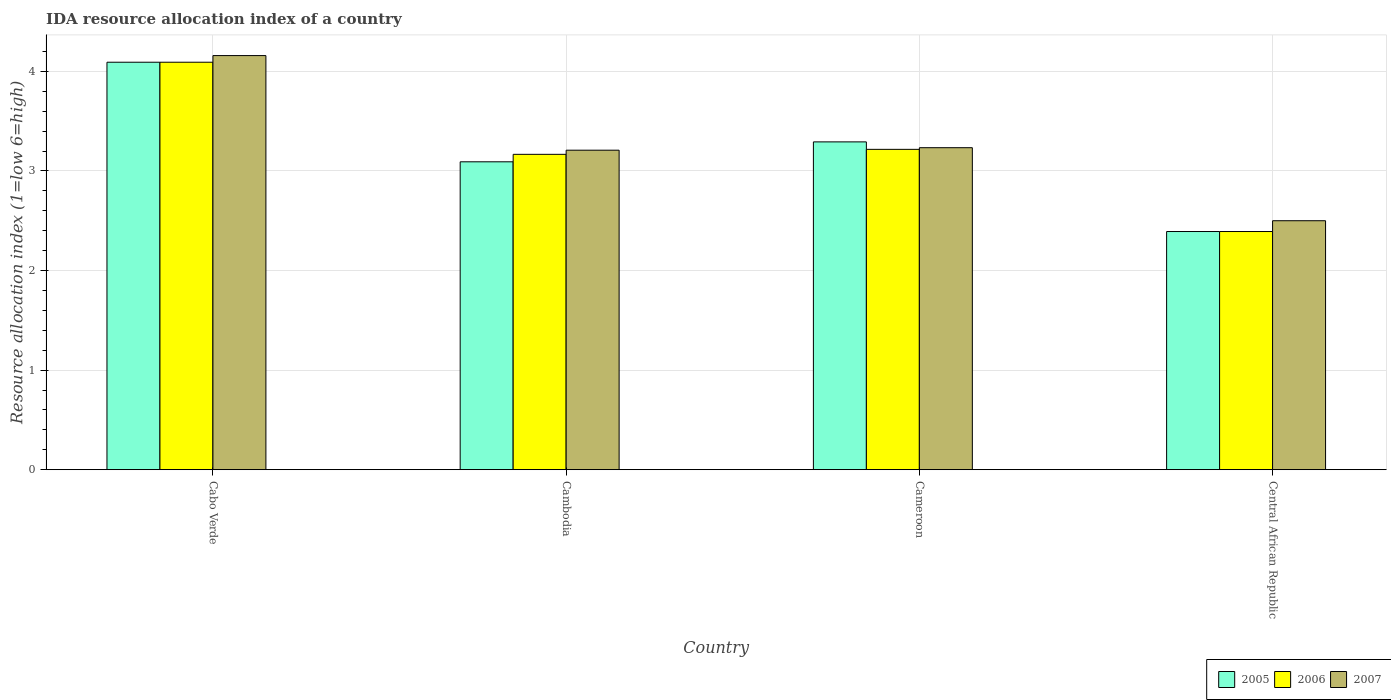How many different coloured bars are there?
Provide a short and direct response. 3. How many groups of bars are there?
Offer a very short reply. 4. How many bars are there on the 2nd tick from the right?
Offer a very short reply. 3. What is the label of the 4th group of bars from the left?
Give a very brief answer. Central African Republic. In how many cases, is the number of bars for a given country not equal to the number of legend labels?
Your answer should be compact. 0. What is the IDA resource allocation index in 2007 in Cameroon?
Keep it short and to the point. 3.23. Across all countries, what is the maximum IDA resource allocation index in 2005?
Offer a very short reply. 4.09. Across all countries, what is the minimum IDA resource allocation index in 2007?
Your response must be concise. 2.5. In which country was the IDA resource allocation index in 2006 maximum?
Your response must be concise. Cabo Verde. In which country was the IDA resource allocation index in 2007 minimum?
Ensure brevity in your answer.  Central African Republic. What is the total IDA resource allocation index in 2006 in the graph?
Your answer should be compact. 12.87. What is the difference between the IDA resource allocation index in 2006 in Cabo Verde and that in Cambodia?
Offer a very short reply. 0.92. What is the difference between the IDA resource allocation index in 2005 in Cambodia and the IDA resource allocation index in 2006 in Cameroon?
Your response must be concise. -0.12. What is the average IDA resource allocation index in 2006 per country?
Make the answer very short. 3.22. What is the difference between the IDA resource allocation index of/in 2005 and IDA resource allocation index of/in 2006 in Cameroon?
Ensure brevity in your answer.  0.08. In how many countries, is the IDA resource allocation index in 2005 greater than 2.2?
Keep it short and to the point. 4. What is the ratio of the IDA resource allocation index in 2007 in Cabo Verde to that in Central African Republic?
Ensure brevity in your answer.  1.66. Is the IDA resource allocation index in 2005 in Cambodia less than that in Central African Republic?
Offer a very short reply. No. Is the difference between the IDA resource allocation index in 2005 in Cambodia and Cameroon greater than the difference between the IDA resource allocation index in 2006 in Cambodia and Cameroon?
Your response must be concise. No. What is the difference between the highest and the second highest IDA resource allocation index in 2006?
Keep it short and to the point. -0.05. What is the difference between the highest and the lowest IDA resource allocation index in 2005?
Give a very brief answer. 1.7. In how many countries, is the IDA resource allocation index in 2006 greater than the average IDA resource allocation index in 2006 taken over all countries?
Ensure brevity in your answer.  2. What does the 3rd bar from the right in Cameroon represents?
Provide a short and direct response. 2005. Are the values on the major ticks of Y-axis written in scientific E-notation?
Ensure brevity in your answer.  No. Does the graph contain any zero values?
Ensure brevity in your answer.  No. Where does the legend appear in the graph?
Make the answer very short. Bottom right. How many legend labels are there?
Ensure brevity in your answer.  3. What is the title of the graph?
Make the answer very short. IDA resource allocation index of a country. Does "1987" appear as one of the legend labels in the graph?
Provide a short and direct response. No. What is the label or title of the X-axis?
Ensure brevity in your answer.  Country. What is the label or title of the Y-axis?
Offer a very short reply. Resource allocation index (1=low 6=high). What is the Resource allocation index (1=low 6=high) of 2005 in Cabo Verde?
Provide a succinct answer. 4.09. What is the Resource allocation index (1=low 6=high) in 2006 in Cabo Verde?
Your answer should be compact. 4.09. What is the Resource allocation index (1=low 6=high) in 2007 in Cabo Verde?
Ensure brevity in your answer.  4.16. What is the Resource allocation index (1=low 6=high) in 2005 in Cambodia?
Your answer should be very brief. 3.09. What is the Resource allocation index (1=low 6=high) in 2006 in Cambodia?
Offer a very short reply. 3.17. What is the Resource allocation index (1=low 6=high) in 2007 in Cambodia?
Make the answer very short. 3.21. What is the Resource allocation index (1=low 6=high) of 2005 in Cameroon?
Provide a short and direct response. 3.29. What is the Resource allocation index (1=low 6=high) in 2006 in Cameroon?
Your response must be concise. 3.22. What is the Resource allocation index (1=low 6=high) of 2007 in Cameroon?
Your response must be concise. 3.23. What is the Resource allocation index (1=low 6=high) of 2005 in Central African Republic?
Offer a very short reply. 2.39. What is the Resource allocation index (1=low 6=high) of 2006 in Central African Republic?
Offer a terse response. 2.39. What is the Resource allocation index (1=low 6=high) of 2007 in Central African Republic?
Your response must be concise. 2.5. Across all countries, what is the maximum Resource allocation index (1=low 6=high) in 2005?
Offer a very short reply. 4.09. Across all countries, what is the maximum Resource allocation index (1=low 6=high) in 2006?
Keep it short and to the point. 4.09. Across all countries, what is the maximum Resource allocation index (1=low 6=high) in 2007?
Offer a very short reply. 4.16. Across all countries, what is the minimum Resource allocation index (1=low 6=high) of 2005?
Keep it short and to the point. 2.39. Across all countries, what is the minimum Resource allocation index (1=low 6=high) of 2006?
Keep it short and to the point. 2.39. What is the total Resource allocation index (1=low 6=high) of 2005 in the graph?
Give a very brief answer. 12.87. What is the total Resource allocation index (1=low 6=high) in 2006 in the graph?
Your response must be concise. 12.87. What is the difference between the Resource allocation index (1=low 6=high) in 2006 in Cabo Verde and that in Cambodia?
Ensure brevity in your answer.  0.93. What is the difference between the Resource allocation index (1=low 6=high) of 2007 in Cabo Verde and that in Cambodia?
Offer a terse response. 0.95. What is the difference between the Resource allocation index (1=low 6=high) in 2005 in Cabo Verde and that in Cameroon?
Make the answer very short. 0.8. What is the difference between the Resource allocation index (1=low 6=high) in 2007 in Cabo Verde and that in Cameroon?
Offer a very short reply. 0.93. What is the difference between the Resource allocation index (1=low 6=high) in 2005 in Cabo Verde and that in Central African Republic?
Give a very brief answer. 1.7. What is the difference between the Resource allocation index (1=low 6=high) in 2006 in Cabo Verde and that in Central African Republic?
Your answer should be very brief. 1.7. What is the difference between the Resource allocation index (1=low 6=high) in 2007 in Cabo Verde and that in Central African Republic?
Offer a terse response. 1.66. What is the difference between the Resource allocation index (1=low 6=high) of 2005 in Cambodia and that in Cameroon?
Ensure brevity in your answer.  -0.2. What is the difference between the Resource allocation index (1=low 6=high) in 2007 in Cambodia and that in Cameroon?
Offer a terse response. -0.03. What is the difference between the Resource allocation index (1=low 6=high) in 2006 in Cambodia and that in Central African Republic?
Ensure brevity in your answer.  0.78. What is the difference between the Resource allocation index (1=low 6=high) of 2007 in Cambodia and that in Central African Republic?
Provide a succinct answer. 0.71. What is the difference between the Resource allocation index (1=low 6=high) of 2006 in Cameroon and that in Central African Republic?
Keep it short and to the point. 0.82. What is the difference between the Resource allocation index (1=low 6=high) of 2007 in Cameroon and that in Central African Republic?
Make the answer very short. 0.73. What is the difference between the Resource allocation index (1=low 6=high) in 2005 in Cabo Verde and the Resource allocation index (1=low 6=high) in 2006 in Cambodia?
Make the answer very short. 0.93. What is the difference between the Resource allocation index (1=low 6=high) of 2005 in Cabo Verde and the Resource allocation index (1=low 6=high) of 2007 in Cambodia?
Your answer should be very brief. 0.88. What is the difference between the Resource allocation index (1=low 6=high) in 2006 in Cabo Verde and the Resource allocation index (1=low 6=high) in 2007 in Cambodia?
Ensure brevity in your answer.  0.88. What is the difference between the Resource allocation index (1=low 6=high) of 2005 in Cabo Verde and the Resource allocation index (1=low 6=high) of 2006 in Cameroon?
Give a very brief answer. 0.88. What is the difference between the Resource allocation index (1=low 6=high) of 2005 in Cabo Verde and the Resource allocation index (1=low 6=high) of 2007 in Cameroon?
Make the answer very short. 0.86. What is the difference between the Resource allocation index (1=low 6=high) of 2006 in Cabo Verde and the Resource allocation index (1=low 6=high) of 2007 in Cameroon?
Your answer should be very brief. 0.86. What is the difference between the Resource allocation index (1=low 6=high) in 2005 in Cabo Verde and the Resource allocation index (1=low 6=high) in 2007 in Central African Republic?
Ensure brevity in your answer.  1.59. What is the difference between the Resource allocation index (1=low 6=high) of 2006 in Cabo Verde and the Resource allocation index (1=low 6=high) of 2007 in Central African Republic?
Offer a very short reply. 1.59. What is the difference between the Resource allocation index (1=low 6=high) in 2005 in Cambodia and the Resource allocation index (1=low 6=high) in 2006 in Cameroon?
Provide a short and direct response. -0.12. What is the difference between the Resource allocation index (1=low 6=high) of 2005 in Cambodia and the Resource allocation index (1=low 6=high) of 2007 in Cameroon?
Offer a very short reply. -0.14. What is the difference between the Resource allocation index (1=low 6=high) of 2006 in Cambodia and the Resource allocation index (1=low 6=high) of 2007 in Cameroon?
Provide a succinct answer. -0.07. What is the difference between the Resource allocation index (1=low 6=high) in 2005 in Cambodia and the Resource allocation index (1=low 6=high) in 2006 in Central African Republic?
Ensure brevity in your answer.  0.7. What is the difference between the Resource allocation index (1=low 6=high) of 2005 in Cambodia and the Resource allocation index (1=low 6=high) of 2007 in Central African Republic?
Make the answer very short. 0.59. What is the difference between the Resource allocation index (1=low 6=high) in 2006 in Cambodia and the Resource allocation index (1=low 6=high) in 2007 in Central African Republic?
Ensure brevity in your answer.  0.67. What is the difference between the Resource allocation index (1=low 6=high) of 2005 in Cameroon and the Resource allocation index (1=low 6=high) of 2006 in Central African Republic?
Ensure brevity in your answer.  0.9. What is the difference between the Resource allocation index (1=low 6=high) in 2005 in Cameroon and the Resource allocation index (1=low 6=high) in 2007 in Central African Republic?
Make the answer very short. 0.79. What is the difference between the Resource allocation index (1=low 6=high) of 2006 in Cameroon and the Resource allocation index (1=low 6=high) of 2007 in Central African Republic?
Provide a short and direct response. 0.72. What is the average Resource allocation index (1=low 6=high) of 2005 per country?
Give a very brief answer. 3.22. What is the average Resource allocation index (1=low 6=high) in 2006 per country?
Give a very brief answer. 3.22. What is the average Resource allocation index (1=low 6=high) in 2007 per country?
Your answer should be compact. 3.27. What is the difference between the Resource allocation index (1=low 6=high) in 2005 and Resource allocation index (1=low 6=high) in 2006 in Cabo Verde?
Provide a succinct answer. 0. What is the difference between the Resource allocation index (1=low 6=high) of 2005 and Resource allocation index (1=low 6=high) of 2007 in Cabo Verde?
Offer a very short reply. -0.07. What is the difference between the Resource allocation index (1=low 6=high) of 2006 and Resource allocation index (1=low 6=high) of 2007 in Cabo Verde?
Your answer should be very brief. -0.07. What is the difference between the Resource allocation index (1=low 6=high) in 2005 and Resource allocation index (1=low 6=high) in 2006 in Cambodia?
Ensure brevity in your answer.  -0.07. What is the difference between the Resource allocation index (1=low 6=high) of 2005 and Resource allocation index (1=low 6=high) of 2007 in Cambodia?
Offer a very short reply. -0.12. What is the difference between the Resource allocation index (1=low 6=high) in 2006 and Resource allocation index (1=low 6=high) in 2007 in Cambodia?
Provide a succinct answer. -0.04. What is the difference between the Resource allocation index (1=low 6=high) of 2005 and Resource allocation index (1=low 6=high) of 2006 in Cameroon?
Keep it short and to the point. 0.07. What is the difference between the Resource allocation index (1=low 6=high) in 2005 and Resource allocation index (1=low 6=high) in 2007 in Cameroon?
Offer a terse response. 0.06. What is the difference between the Resource allocation index (1=low 6=high) of 2006 and Resource allocation index (1=low 6=high) of 2007 in Cameroon?
Provide a short and direct response. -0.02. What is the difference between the Resource allocation index (1=low 6=high) of 2005 and Resource allocation index (1=low 6=high) of 2007 in Central African Republic?
Your answer should be very brief. -0.11. What is the difference between the Resource allocation index (1=low 6=high) in 2006 and Resource allocation index (1=low 6=high) in 2007 in Central African Republic?
Make the answer very short. -0.11. What is the ratio of the Resource allocation index (1=low 6=high) of 2005 in Cabo Verde to that in Cambodia?
Ensure brevity in your answer.  1.32. What is the ratio of the Resource allocation index (1=low 6=high) of 2006 in Cabo Verde to that in Cambodia?
Keep it short and to the point. 1.29. What is the ratio of the Resource allocation index (1=low 6=high) in 2007 in Cabo Verde to that in Cambodia?
Your answer should be compact. 1.3. What is the ratio of the Resource allocation index (1=low 6=high) in 2005 in Cabo Verde to that in Cameroon?
Give a very brief answer. 1.24. What is the ratio of the Resource allocation index (1=low 6=high) of 2006 in Cabo Verde to that in Cameroon?
Ensure brevity in your answer.  1.27. What is the ratio of the Resource allocation index (1=low 6=high) of 2007 in Cabo Verde to that in Cameroon?
Ensure brevity in your answer.  1.29. What is the ratio of the Resource allocation index (1=low 6=high) in 2005 in Cabo Verde to that in Central African Republic?
Offer a terse response. 1.71. What is the ratio of the Resource allocation index (1=low 6=high) of 2006 in Cabo Verde to that in Central African Republic?
Provide a short and direct response. 1.71. What is the ratio of the Resource allocation index (1=low 6=high) in 2007 in Cabo Verde to that in Central African Republic?
Keep it short and to the point. 1.66. What is the ratio of the Resource allocation index (1=low 6=high) of 2005 in Cambodia to that in Cameroon?
Your answer should be very brief. 0.94. What is the ratio of the Resource allocation index (1=low 6=high) in 2006 in Cambodia to that in Cameroon?
Make the answer very short. 0.98. What is the ratio of the Resource allocation index (1=low 6=high) of 2005 in Cambodia to that in Central African Republic?
Offer a terse response. 1.29. What is the ratio of the Resource allocation index (1=low 6=high) in 2006 in Cambodia to that in Central African Republic?
Your response must be concise. 1.32. What is the ratio of the Resource allocation index (1=low 6=high) of 2007 in Cambodia to that in Central African Republic?
Keep it short and to the point. 1.28. What is the ratio of the Resource allocation index (1=low 6=high) of 2005 in Cameroon to that in Central African Republic?
Keep it short and to the point. 1.38. What is the ratio of the Resource allocation index (1=low 6=high) of 2006 in Cameroon to that in Central African Republic?
Make the answer very short. 1.34. What is the ratio of the Resource allocation index (1=low 6=high) of 2007 in Cameroon to that in Central African Republic?
Ensure brevity in your answer.  1.29. What is the difference between the highest and the second highest Resource allocation index (1=low 6=high) in 2005?
Provide a short and direct response. 0.8. What is the difference between the highest and the second highest Resource allocation index (1=low 6=high) in 2006?
Offer a very short reply. 0.88. What is the difference between the highest and the second highest Resource allocation index (1=low 6=high) of 2007?
Make the answer very short. 0.93. What is the difference between the highest and the lowest Resource allocation index (1=low 6=high) in 2006?
Offer a terse response. 1.7. What is the difference between the highest and the lowest Resource allocation index (1=low 6=high) of 2007?
Provide a short and direct response. 1.66. 